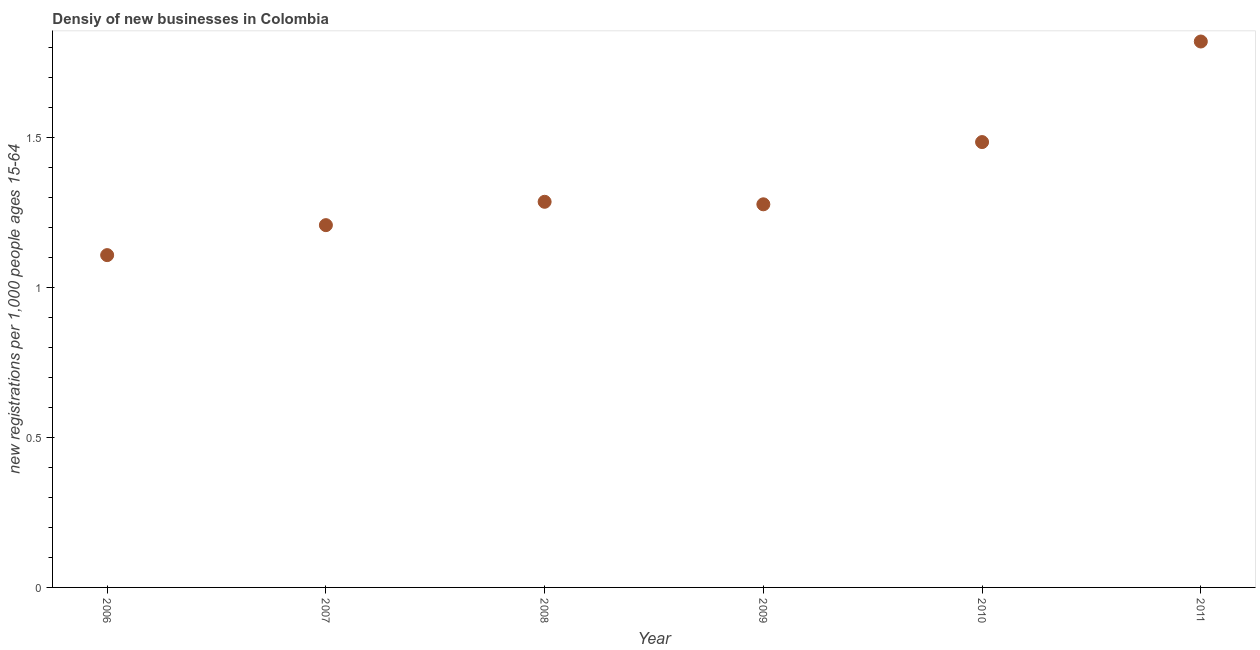What is the density of new business in 2006?
Keep it short and to the point. 1.11. Across all years, what is the maximum density of new business?
Make the answer very short. 1.82. Across all years, what is the minimum density of new business?
Provide a succinct answer. 1.11. In which year was the density of new business maximum?
Ensure brevity in your answer.  2011. What is the sum of the density of new business?
Keep it short and to the point. 8.19. What is the difference between the density of new business in 2006 and 2009?
Ensure brevity in your answer.  -0.17. What is the average density of new business per year?
Offer a terse response. 1.36. What is the median density of new business?
Keep it short and to the point. 1.28. In how many years, is the density of new business greater than 0.5 ?
Make the answer very short. 6. Do a majority of the years between 2009 and 2011 (inclusive) have density of new business greater than 0.8 ?
Your response must be concise. Yes. What is the ratio of the density of new business in 2010 to that in 2011?
Provide a short and direct response. 0.82. Is the difference between the density of new business in 2006 and 2008 greater than the difference between any two years?
Your response must be concise. No. What is the difference between the highest and the second highest density of new business?
Make the answer very short. 0.34. Is the sum of the density of new business in 2009 and 2010 greater than the maximum density of new business across all years?
Provide a succinct answer. Yes. What is the difference between the highest and the lowest density of new business?
Offer a very short reply. 0.71. Does the density of new business monotonically increase over the years?
Make the answer very short. No. What is the difference between two consecutive major ticks on the Y-axis?
Provide a short and direct response. 0.5. Does the graph contain grids?
Your response must be concise. No. What is the title of the graph?
Your answer should be very brief. Densiy of new businesses in Colombia. What is the label or title of the X-axis?
Offer a terse response. Year. What is the label or title of the Y-axis?
Provide a succinct answer. New registrations per 1,0 people ages 15-64. What is the new registrations per 1,000 people ages 15-64 in 2006?
Provide a succinct answer. 1.11. What is the new registrations per 1,000 people ages 15-64 in 2007?
Your response must be concise. 1.21. What is the new registrations per 1,000 people ages 15-64 in 2008?
Keep it short and to the point. 1.29. What is the new registrations per 1,000 people ages 15-64 in 2009?
Make the answer very short. 1.28. What is the new registrations per 1,000 people ages 15-64 in 2010?
Your answer should be compact. 1.49. What is the new registrations per 1,000 people ages 15-64 in 2011?
Your answer should be very brief. 1.82. What is the difference between the new registrations per 1,000 people ages 15-64 in 2006 and 2007?
Provide a succinct answer. -0.1. What is the difference between the new registrations per 1,000 people ages 15-64 in 2006 and 2008?
Your response must be concise. -0.18. What is the difference between the new registrations per 1,000 people ages 15-64 in 2006 and 2009?
Offer a very short reply. -0.17. What is the difference between the new registrations per 1,000 people ages 15-64 in 2006 and 2010?
Offer a very short reply. -0.38. What is the difference between the new registrations per 1,000 people ages 15-64 in 2006 and 2011?
Make the answer very short. -0.71. What is the difference between the new registrations per 1,000 people ages 15-64 in 2007 and 2008?
Make the answer very short. -0.08. What is the difference between the new registrations per 1,000 people ages 15-64 in 2007 and 2009?
Keep it short and to the point. -0.07. What is the difference between the new registrations per 1,000 people ages 15-64 in 2007 and 2010?
Give a very brief answer. -0.28. What is the difference between the new registrations per 1,000 people ages 15-64 in 2007 and 2011?
Provide a short and direct response. -0.61. What is the difference between the new registrations per 1,000 people ages 15-64 in 2008 and 2009?
Your answer should be very brief. 0.01. What is the difference between the new registrations per 1,000 people ages 15-64 in 2008 and 2010?
Your response must be concise. -0.2. What is the difference between the new registrations per 1,000 people ages 15-64 in 2008 and 2011?
Ensure brevity in your answer.  -0.53. What is the difference between the new registrations per 1,000 people ages 15-64 in 2009 and 2010?
Your answer should be very brief. -0.21. What is the difference between the new registrations per 1,000 people ages 15-64 in 2009 and 2011?
Your answer should be very brief. -0.54. What is the difference between the new registrations per 1,000 people ages 15-64 in 2010 and 2011?
Provide a short and direct response. -0.34. What is the ratio of the new registrations per 1,000 people ages 15-64 in 2006 to that in 2007?
Offer a very short reply. 0.92. What is the ratio of the new registrations per 1,000 people ages 15-64 in 2006 to that in 2008?
Your answer should be very brief. 0.86. What is the ratio of the new registrations per 1,000 people ages 15-64 in 2006 to that in 2009?
Keep it short and to the point. 0.87. What is the ratio of the new registrations per 1,000 people ages 15-64 in 2006 to that in 2010?
Offer a very short reply. 0.75. What is the ratio of the new registrations per 1,000 people ages 15-64 in 2006 to that in 2011?
Make the answer very short. 0.61. What is the ratio of the new registrations per 1,000 people ages 15-64 in 2007 to that in 2008?
Make the answer very short. 0.94. What is the ratio of the new registrations per 1,000 people ages 15-64 in 2007 to that in 2009?
Ensure brevity in your answer.  0.95. What is the ratio of the new registrations per 1,000 people ages 15-64 in 2007 to that in 2010?
Keep it short and to the point. 0.81. What is the ratio of the new registrations per 1,000 people ages 15-64 in 2007 to that in 2011?
Make the answer very short. 0.66. What is the ratio of the new registrations per 1,000 people ages 15-64 in 2008 to that in 2009?
Your response must be concise. 1.01. What is the ratio of the new registrations per 1,000 people ages 15-64 in 2008 to that in 2010?
Keep it short and to the point. 0.87. What is the ratio of the new registrations per 1,000 people ages 15-64 in 2008 to that in 2011?
Your answer should be compact. 0.71. What is the ratio of the new registrations per 1,000 people ages 15-64 in 2009 to that in 2010?
Make the answer very short. 0.86. What is the ratio of the new registrations per 1,000 people ages 15-64 in 2009 to that in 2011?
Ensure brevity in your answer.  0.7. What is the ratio of the new registrations per 1,000 people ages 15-64 in 2010 to that in 2011?
Provide a succinct answer. 0.82. 